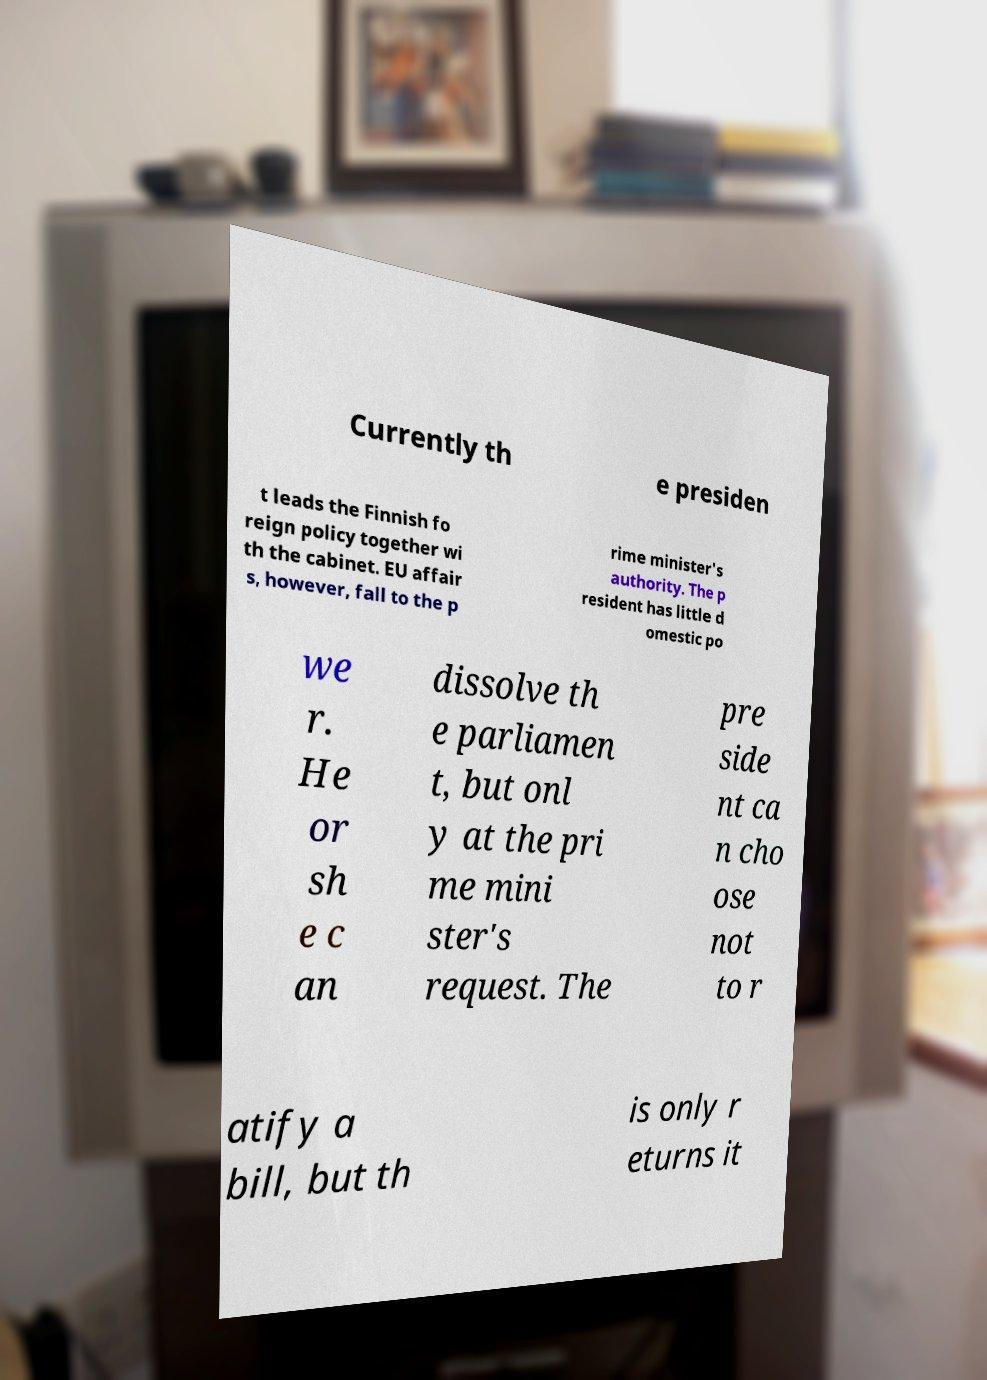Could you extract and type out the text from this image? Currently th e presiden t leads the Finnish fo reign policy together wi th the cabinet. EU affair s, however, fall to the p rime minister's authority. The p resident has little d omestic po we r. He or sh e c an dissolve th e parliamen t, but onl y at the pri me mini ster's request. The pre side nt ca n cho ose not to r atify a bill, but th is only r eturns it 